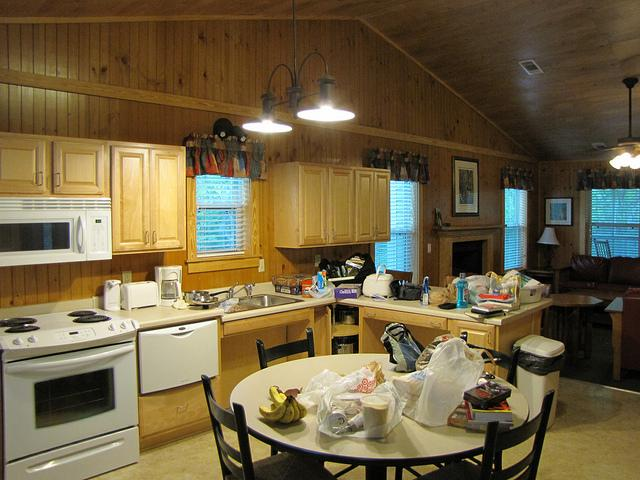What is on top of the dining table? Please explain your reasoning. bananas. The other options aren't on the table. 